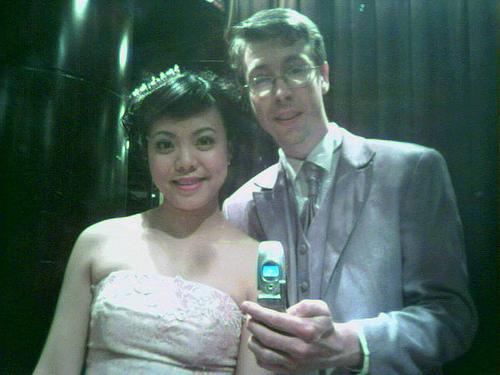What is the man using the phone to do?

Choices:
A) play games
B) take picture
C) make call
D) text take picture 